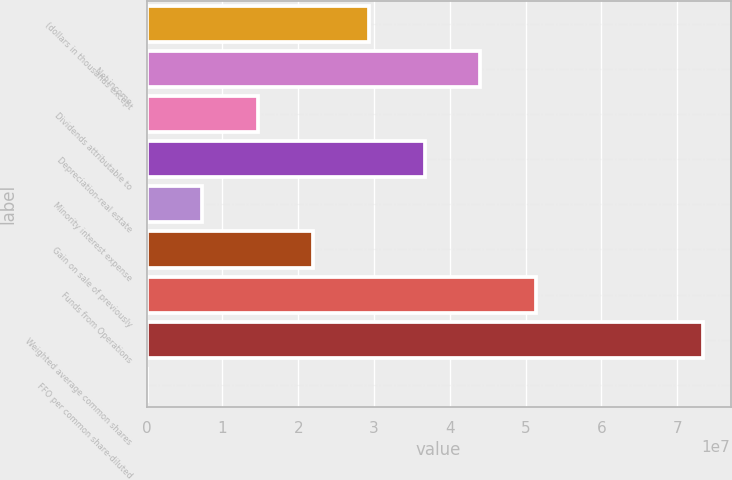<chart> <loc_0><loc_0><loc_500><loc_500><bar_chart><fcel>(dollars in thousands except<fcel>Net income<fcel>Dividends attributable to<fcel>Depreciation-real estate<fcel>Minority interest expense<fcel>Gain on sale of previously<fcel>Funds from Operations<fcel>Weighted average common shares<fcel>FFO per common share-diluted<nl><fcel>2.9342e+07<fcel>4.4013e+07<fcel>1.4671e+07<fcel>3.66775e+07<fcel>7.3355e+06<fcel>2.20065e+07<fcel>5.13485e+07<fcel>7.3355e+07<fcel>3.36<nl></chart> 